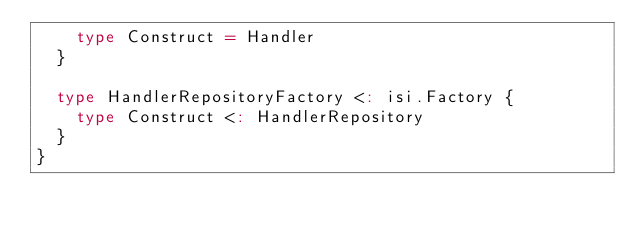Convert code to text. <code><loc_0><loc_0><loc_500><loc_500><_Scala_>    type Construct = Handler
  }

  type HandlerRepositoryFactory <: isi.Factory {
    type Construct <: HandlerRepository
  }
}
</code> 